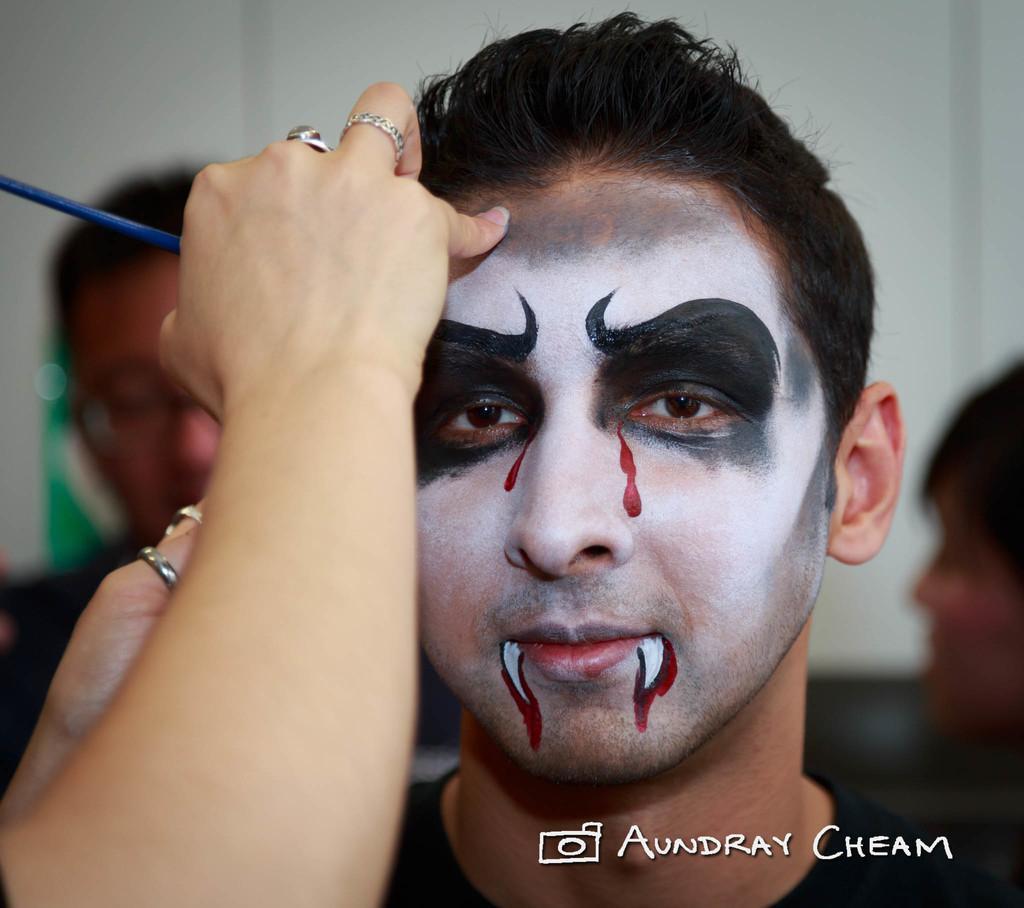How would you summarize this image in a sentence or two? In this image we can see there is a hand of the person painting on the face of the other person, behind them there are a few people and in the background there is a wall. At the bottom of the image there is some text. 